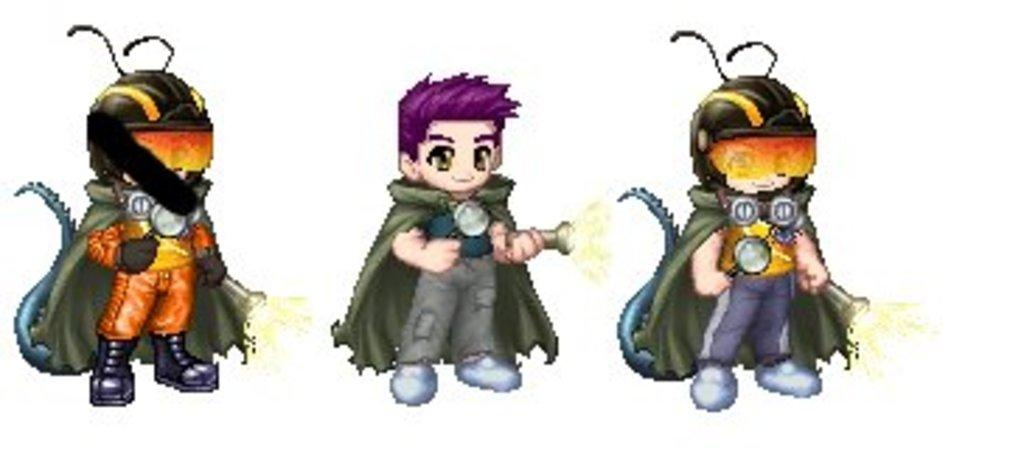What type of characters are present in the image? There are cartoon characters in the image. What are the cartoon characters wearing? The cartoon characters are wearing multi-color dresses. What color is the background of the image? The background of the image is white. Are there any fairies playing in the yard in the image? There are no fairies or yards present in the image; it features cartoon characters wearing multi-color dresses against a white background. 